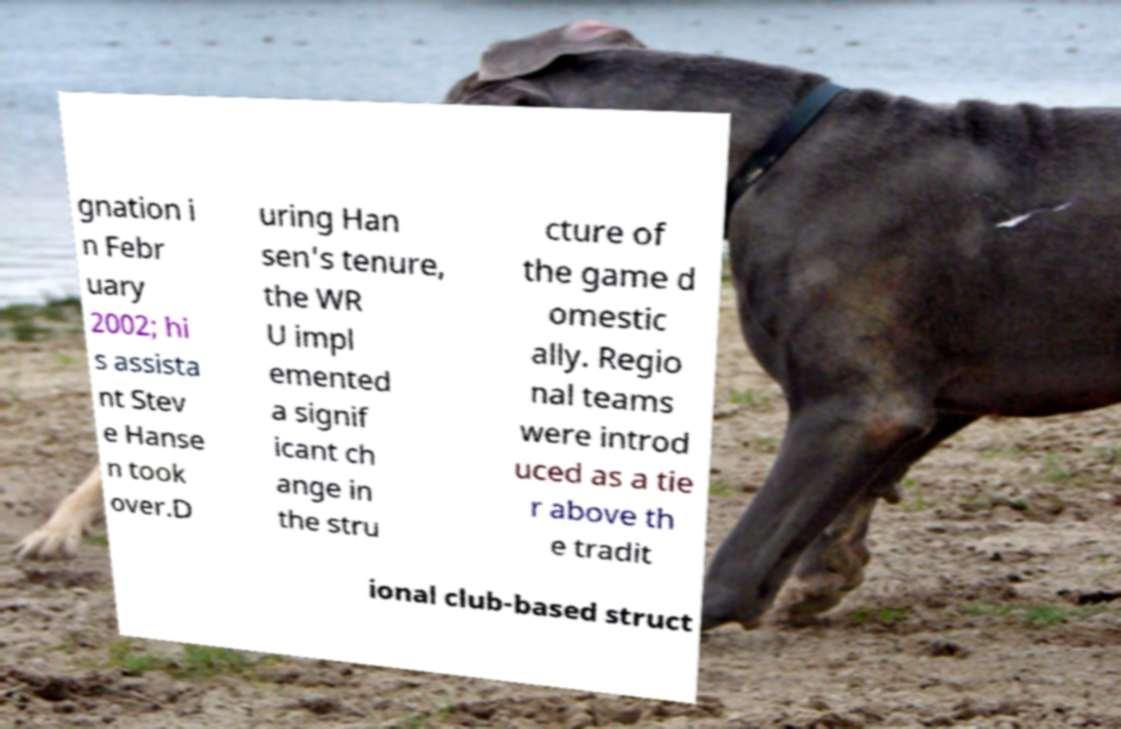Can you accurately transcribe the text from the provided image for me? gnation i n Febr uary 2002; hi s assista nt Stev e Hanse n took over.D uring Han sen's tenure, the WR U impl emented a signif icant ch ange in the stru cture of the game d omestic ally. Regio nal teams were introd uced as a tie r above th e tradit ional club-based struct 